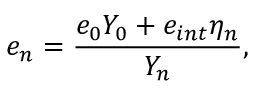Convert formula to latex. <formula><loc_0><loc_0><loc_500><loc_500>e _ { n } = \frac { e _ { 0 } Y _ { 0 } + e _ { i n t } \eta _ { n } } { Y _ { n } } ,</formula> 